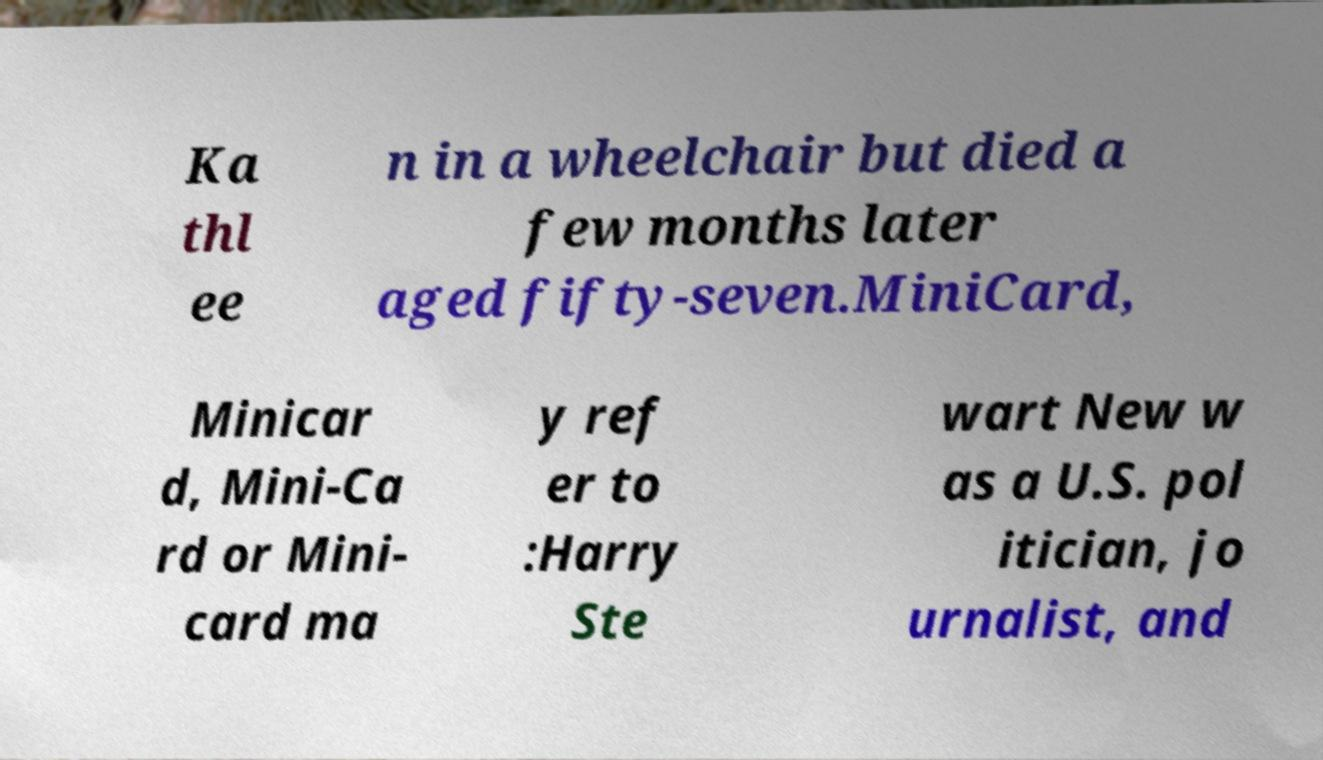Can you read and provide the text displayed in the image?This photo seems to have some interesting text. Can you extract and type it out for me? Ka thl ee n in a wheelchair but died a few months later aged fifty-seven.MiniCard, Minicar d, Mini-Ca rd or Mini- card ma y ref er to :Harry Ste wart New w as a U.S. pol itician, jo urnalist, and 